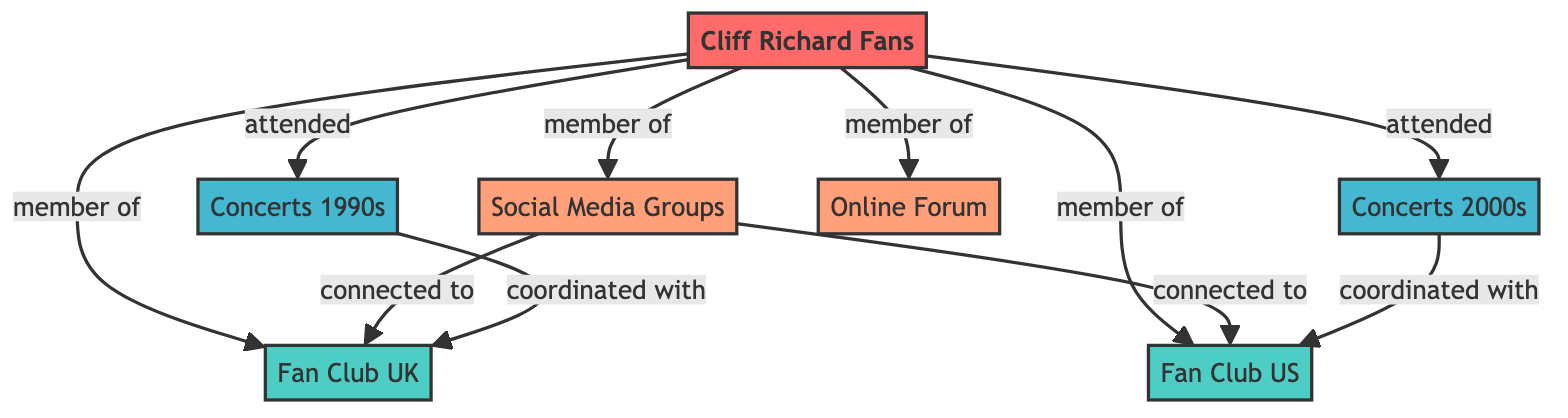What is the total number of nodes in the diagram? The diagram contains 6 distinct nodes: "Cliff Richard Fans," "Cliff Richard Fan Club UK," "Cliff Richard Fan Club US," "Cliff Richard Concerts (1990s)," "Cliff Richard Concerts (2000s)," "Cliff Richard Social Media Groups," and "Cliff Richard Online Forum." By counting each of these unique identifiers, we arrive at the total.
Answer: 6 What is the relationship between "Cliff Richard Fans" and "Cliff Richard Fan Club UK"? In the diagram, "Cliff Richard Fans" has a direct edge labeled "member_of" connecting to "Cliff Richard Fan Club UK." This indicates that fans are members of this fan club. By observing the edge and its label, we can conclude the nature of their relationship.
Answer: member_of Which clubs are connected to the "Cliff Richard Social Media Groups"? The "Cliff Richard Social Media Groups" is connected to both "Cliff Richard Fan Club UK" and "Cliff Richard Fan Club US," as evidenced by the edges labeled "connected_to" leading to each fan club. By analyzing the connections, we identify these two clubs.
Answer: Cliff Richard Fan Club UK, Cliff Richard Fan Club US How many edges are present in the diagram? The diagram includes 10 edges, connecting the various nodes through different relationships. By counting each connection listed in the edges section, we confirm the total number of edges.
Answer: 10 Which events did "Cliff Richard Fans" attend in the 1990s? "Cliff Richard Fans" attended the "Cliff Richard Concerts (1990s)," as indicated by the direct edge labeled "attended" leading to this event node. By checking the connections, we identify the event that fans participated in.
Answer: Cliff Richard Concerts (1990s) What type of relationship exists between "Cliff Richard Concerts (2000s)" and "Cliff Richard Fan Club US"? The relationship displayed in the diagram is indicated by the edge labeled "coordinated_with," showing that the concerts in the 2000s were coordinated with the fan club located in the US. By examining the edge label, we understand the nature of their collaboration.
Answer: coordinated_with How many modern network connections are present in the diagram? There are 4 entities categorized under the modern network: "Cliff Richard Social Media Groups" and "Cliff Richard Online Forum." Both are connected to the "Cliff Richard Fans," leading to a total of 4 modern network connections (2 connections to bars from "Cliff Richard Fans" and 2 connections to fan clubs).
Answer: 4 